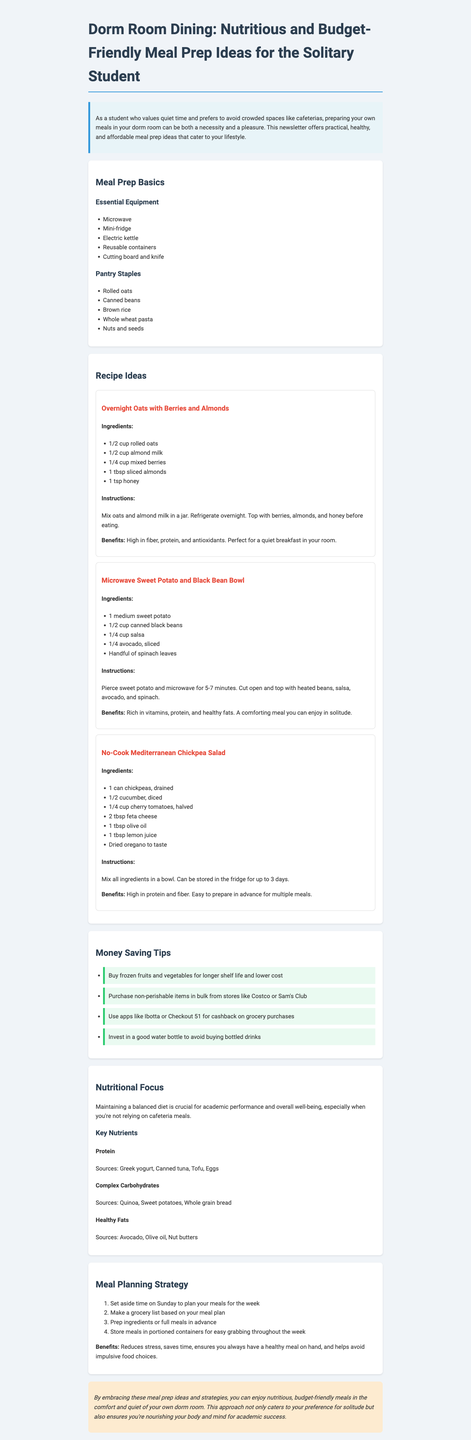What is the newsletter title? The title is highlighted clearly at the beginning of the document.
Answer: Dorm Room Dining: Nutritious and Budget-Friendly Meal Prep Ideas for the Solitary Student How many essential equipment items are listed? The total number of essential equipment items can be counted in the section.
Answer: 5 What is the key benefit of Overnight Oats with Berries and Almonds? The benefits of the recipe are outlined in the recipe section.
Answer: High in fiber, protein, and antioxidants What meal can be made using just canned ingredients? The document describes several meals, but this one specifically uses canned items prominently.
Answer: No-Cook Mediterranean Chickpea Salad What nutrient sources are listed under Healthy Fats? The document provides a brief list of sources for key nutrients.
Answer: Avocado, Olive oil, Nut butters What is one of the money-saving tips? The document includes several practical tips for saving money on groceries.
Answer: Buy frozen fruits and vegetables for longer shelf life and lower cost What is the primary focus of the nutritional section? The document begins with a statement about the importance of balanced nutrition.
Answer: Maintaining a balanced diet is crucial for academic performance and overall well-being How long can the Mediterranean Chickpea Salad be stored? This information is found in the recipe's instructions.
Answer: Up to 3 days 